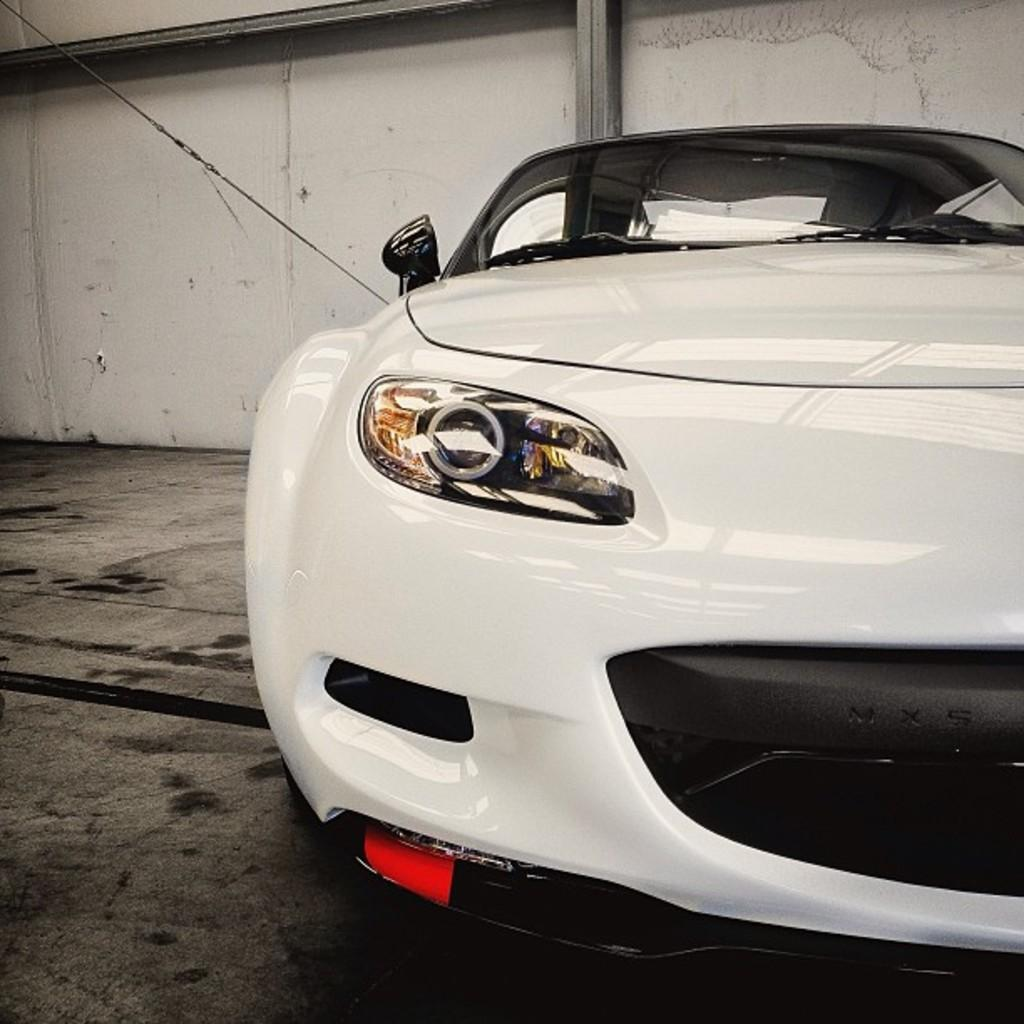Where was the image taken? The image is taken indoors. What type of vehicle is in the image? There is a white color car in the image. How is the car positioned in the image? The car is parked on the ground. What can be seen in the background of the image? There is a cable, a wall, and metal rods visible in the background of the image. What type of jelly can be seen on the car's windshield in the image? There is no jelly present on the car's windshield in the image. How does the patch on the wall affect the car's position in the image? There is no patch mentioned on the wall in the image, so it cannot affect the car's position. 